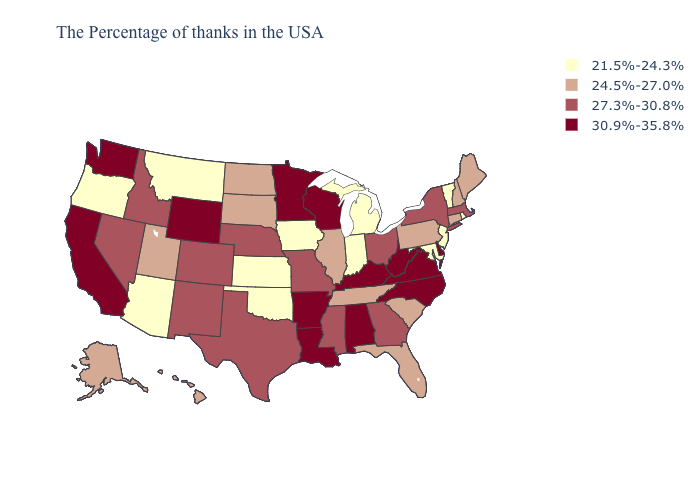Among the states that border Oklahoma , does Kansas have the lowest value?
Write a very short answer. Yes. What is the value of Idaho?
Concise answer only. 27.3%-30.8%. What is the highest value in the Northeast ?
Keep it brief. 27.3%-30.8%. Among the states that border West Virginia , does Virginia have the highest value?
Quick response, please. Yes. Name the states that have a value in the range 30.9%-35.8%?
Write a very short answer. Delaware, Virginia, North Carolina, West Virginia, Kentucky, Alabama, Wisconsin, Louisiana, Arkansas, Minnesota, Wyoming, California, Washington. Does North Dakota have the lowest value in the MidWest?
Short answer required. No. What is the lowest value in the USA?
Concise answer only. 21.5%-24.3%. Does Tennessee have a higher value than Michigan?
Concise answer only. Yes. Name the states that have a value in the range 21.5%-24.3%?
Give a very brief answer. Rhode Island, Vermont, New Jersey, Maryland, Michigan, Indiana, Iowa, Kansas, Oklahoma, Montana, Arizona, Oregon. Does the first symbol in the legend represent the smallest category?
Keep it brief. Yes. Name the states that have a value in the range 30.9%-35.8%?
Give a very brief answer. Delaware, Virginia, North Carolina, West Virginia, Kentucky, Alabama, Wisconsin, Louisiana, Arkansas, Minnesota, Wyoming, California, Washington. Does the map have missing data?
Answer briefly. No. What is the value of New Hampshire?
Give a very brief answer. 24.5%-27.0%. Does North Dakota have a higher value than New Jersey?
Be succinct. Yes. What is the value of Alabama?
Concise answer only. 30.9%-35.8%. 